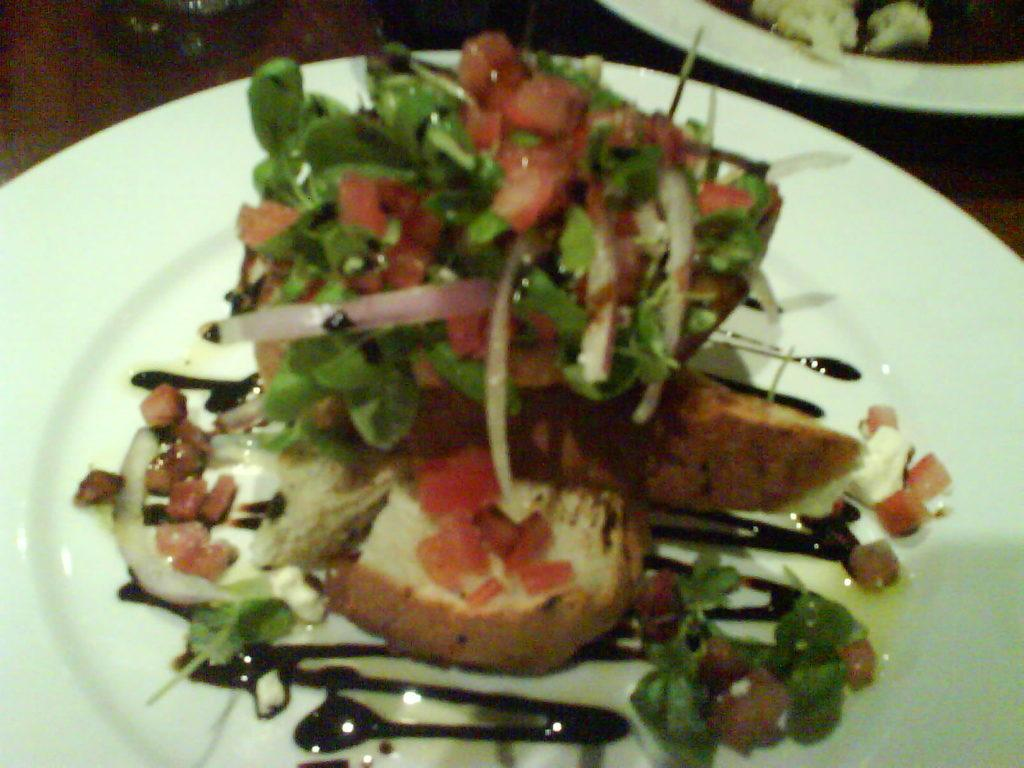What is on the white plate in the image? The plate contains breads, tomato, mint, and other vegetable pieces. What else can be seen on the table in the image? There is a glass and other plates on the table in the image. Are there any visible lines on the table or any other objects? Yes, there are chocolate lines visible in the image. What advice does the farmer give to the trucks in the image? There is no farmer or trucks present in the image, so it is not possible to answer that question. 